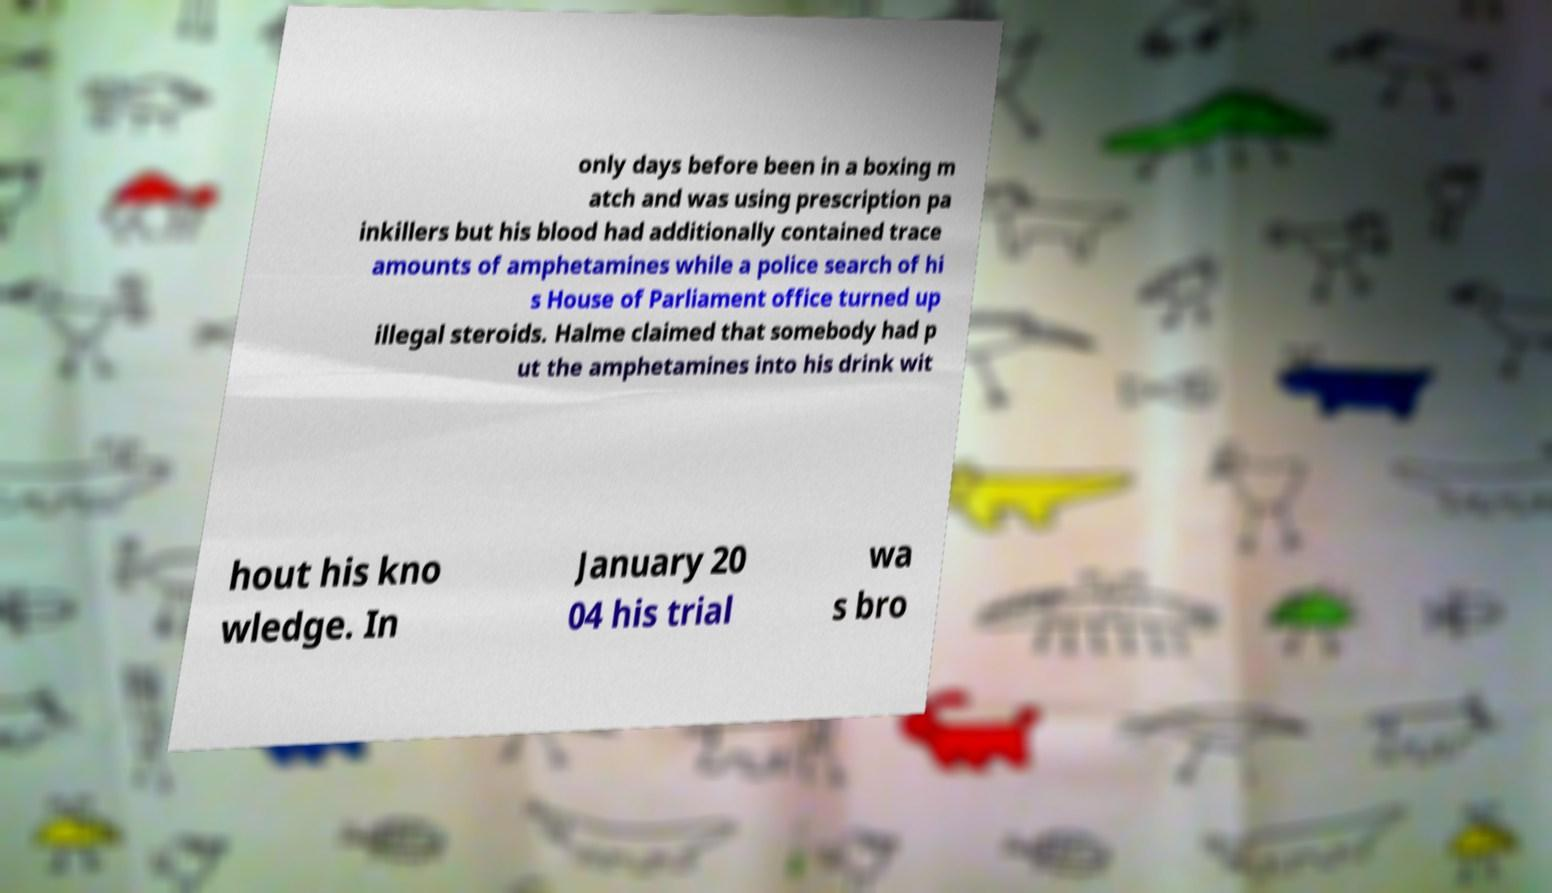There's text embedded in this image that I need extracted. Can you transcribe it verbatim? only days before been in a boxing m atch and was using prescription pa inkillers but his blood had additionally contained trace amounts of amphetamines while a police search of hi s House of Parliament office turned up illegal steroids. Halme claimed that somebody had p ut the amphetamines into his drink wit hout his kno wledge. In January 20 04 his trial wa s bro 